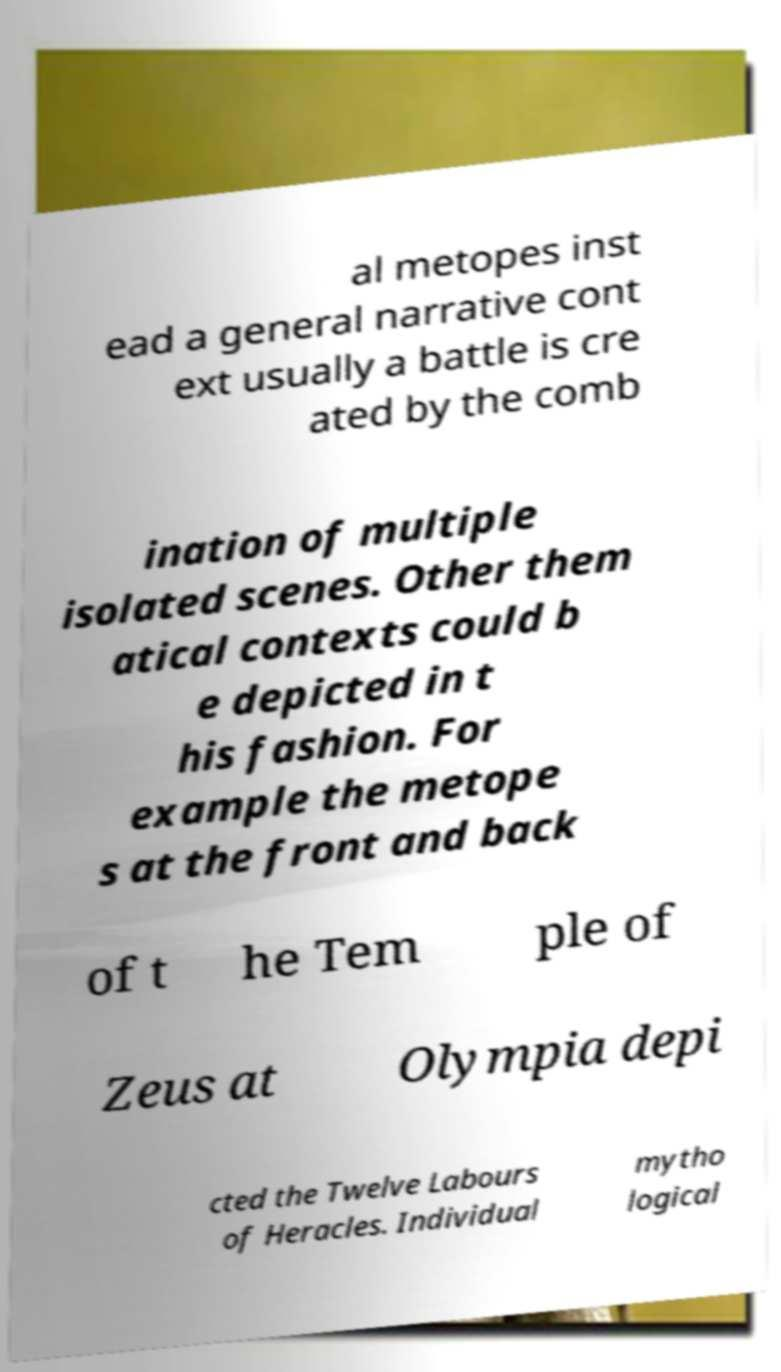Can you accurately transcribe the text from the provided image for me? al metopes inst ead a general narrative cont ext usually a battle is cre ated by the comb ination of multiple isolated scenes. Other them atical contexts could b e depicted in t his fashion. For example the metope s at the front and back of t he Tem ple of Zeus at Olympia depi cted the Twelve Labours of Heracles. Individual mytho logical 